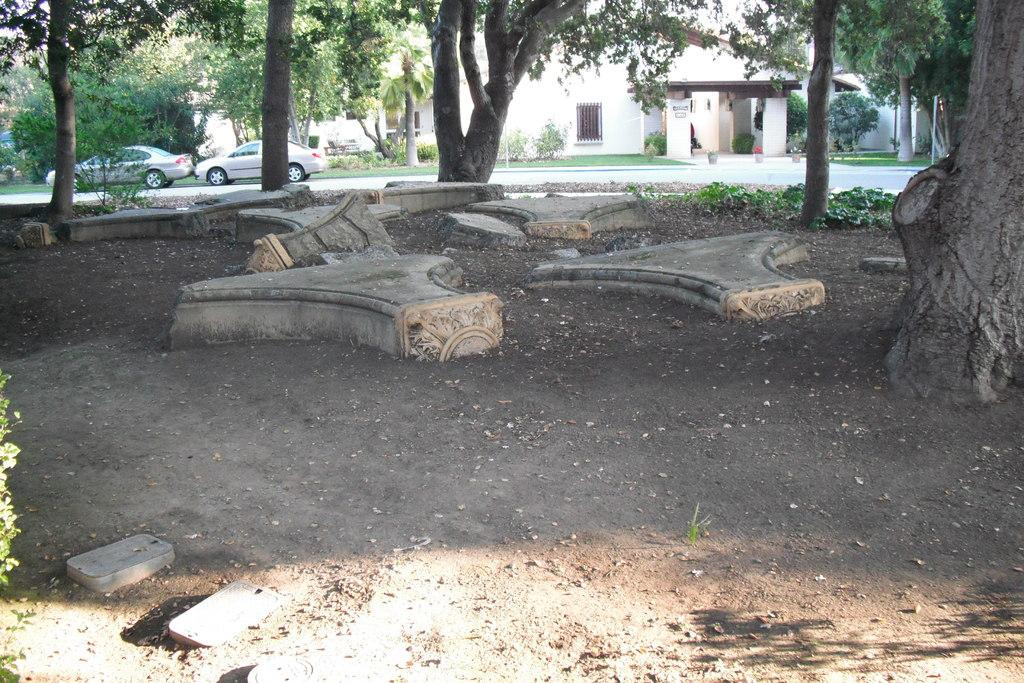What type of vegetation can be seen in the image? There are trees in the image. What structures are visible in the background of the image? There are buildings in the background of the image. How many cars are on the left side of the image? There are two cars on the left side of the image. What type of plants are at the bottom of the image? There are plants at the bottom of the image. What type of ground cover is visible in the image? There is grass visible in the image. How many knives are lying on the grass in the image? There are no knives present in the image. What type of bean is growing on the trees in the image? There are no beans growing on the trees in the image; it features trees and buildings. 